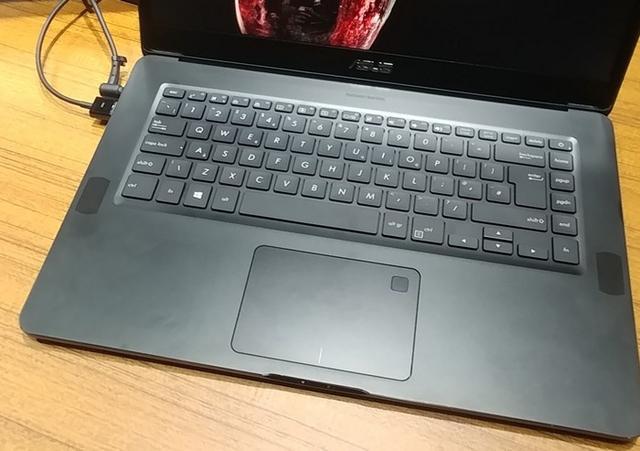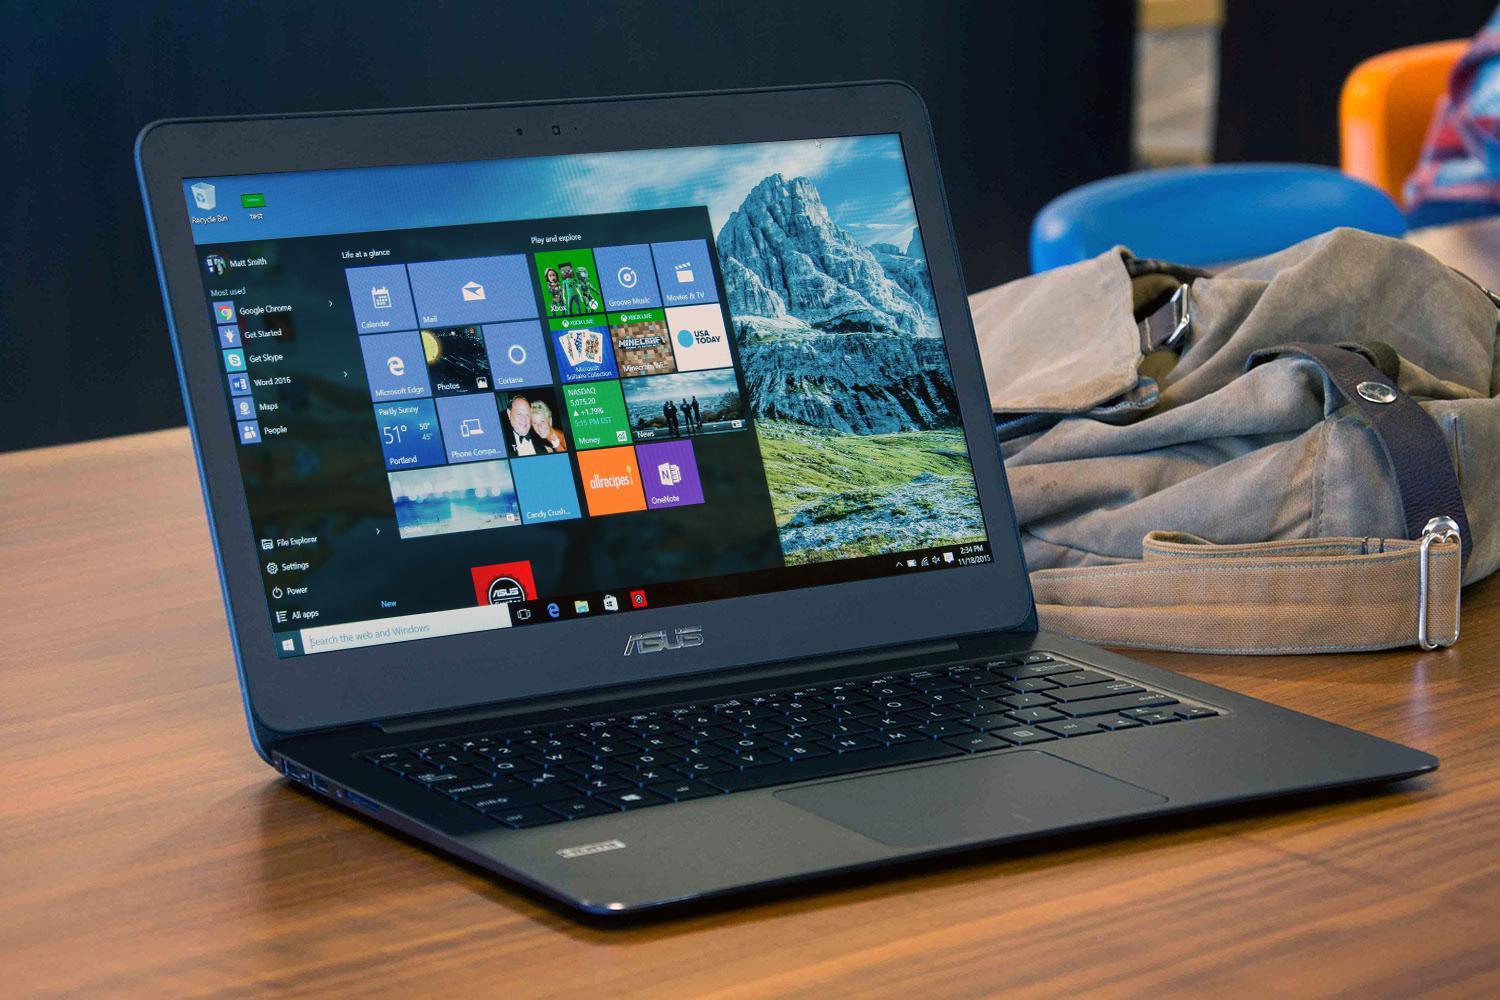The first image is the image on the left, the second image is the image on the right. For the images displayed, is the sentence "Each image shows one open laptop, and the lefthand laptop has a cord plugged into its right side." factually correct? Answer yes or no. No. The first image is the image on the left, the second image is the image on the right. Assess this claim about the two images: "There are multiple squares shown on a laptop screen in one of the images.". Correct or not? Answer yes or no. Yes. 